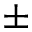<formula> <loc_0><loc_0><loc_500><loc_500>\pm</formula> 